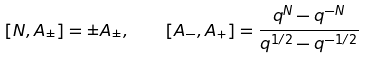Convert formula to latex. <formula><loc_0><loc_0><loc_500><loc_500>[ N , A _ { \pm } ] = \pm A _ { \pm } , \quad [ A _ { - } , A _ { + } ] = \frac { q ^ { N } - q ^ { - N } } { q ^ { 1 / 2 } - q ^ { - 1 / 2 } }</formula> 